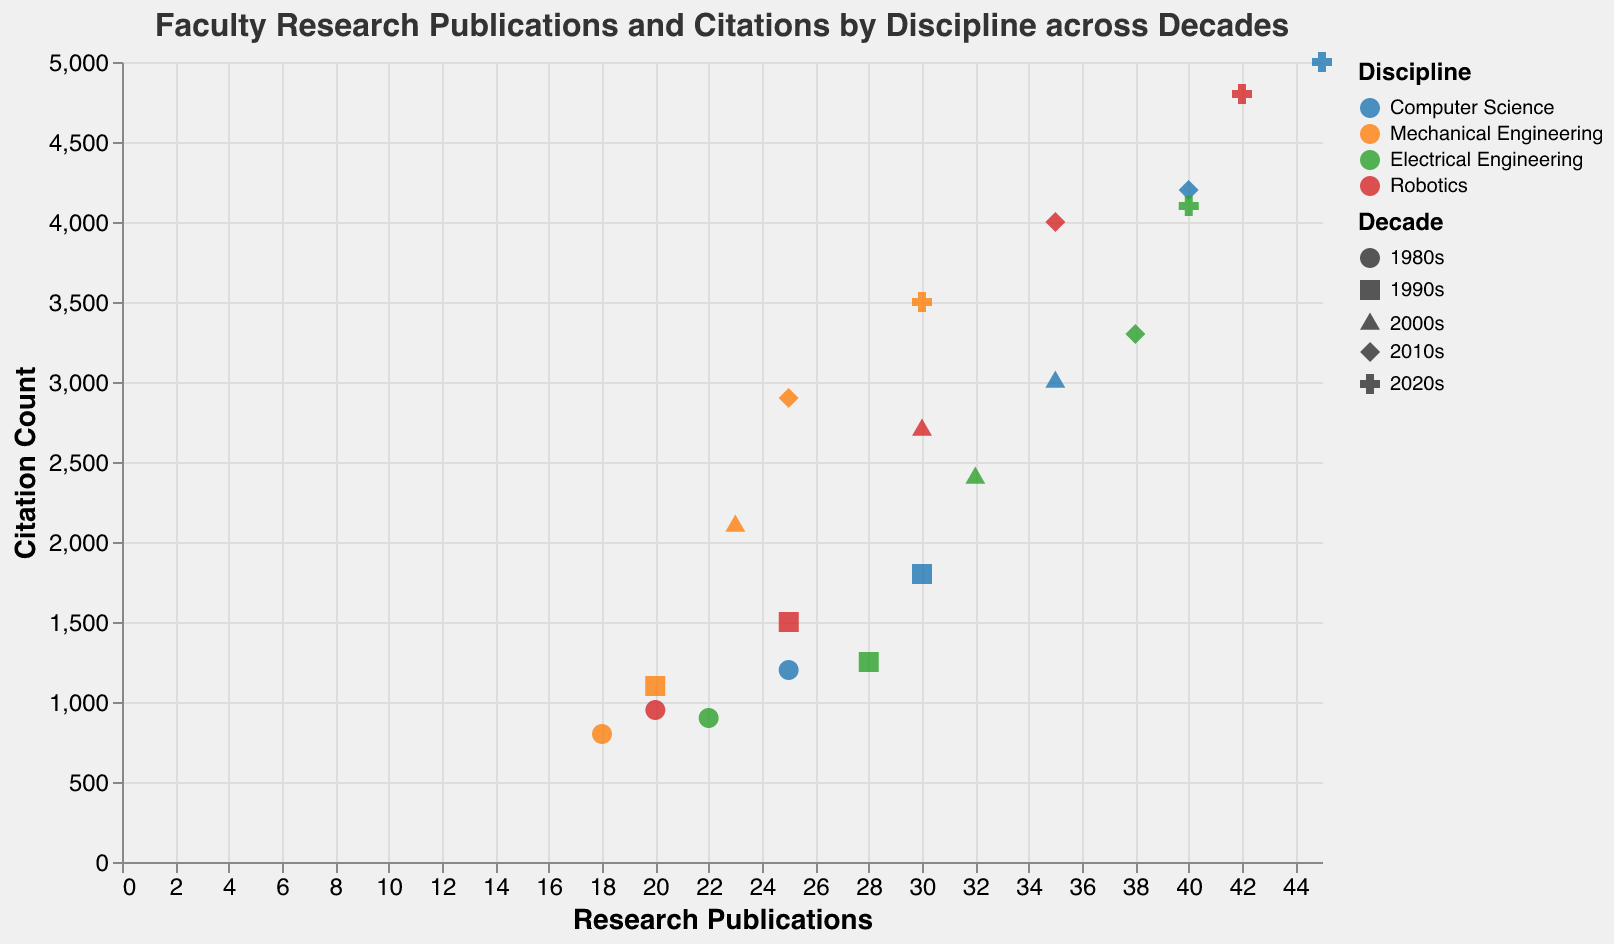What is the title of the plot? The title is located at the top of the plot and it says "Faculty Research Publications and Citations by Discipline across Decades".
Answer: Faculty Research Publications and Citations by Discipline across Decades Which discipline had the highest citation count in the 2020s? By observing the data points marked with the shape corresponding to the 2020s and comparing their citation counts, Robotics had the highest count.
Answer: Robotics How many disciplines are represented in the plot? The color legend indicates the number of different disciplines shown, which are four: Computer Science, Mechanical Engineering, Electrical Engineering, and Robotics.
Answer: 4 What shape represents the data points from the 2000s? The legend for shape indicates which shapes correspond to which decade; the triangle is used for the 2000s.
Answer: Triangle Which decade shows the highest number of research publications for Computer Science? By comparing the shapes corresponding to Computer Science across the different decades, the 2020s (represented by the cross) has the highest number of research publications for Computer Science.
Answer: 2020s What is the average citation count for Electrical Engineering in the 1990s and 2000s combined? Locate the citation counts for Electrical Engineering in the 1990s (1250) and 2000s (2400), sum them up (1250 + 2400 = 3650), and divide by 2 to get the average (3650 / 2 = 1825).
Answer: 1825 Compare the research publications of Robotics between the 1980s and 2020s. How much did it increase? The research publications for Robotics in the 1980s are 20 and in the 2020s are 42. The increase is calculated as 42 - 20 = 22.
Answer: 22 Which discipline had the least growth in citation count from the 1980s to the 2020s? By calculating the difference in citation counts for each discipline between the 1980s and 2020s, Mechanical Engineering increased from 800 to 3500, which is the smallest increase when compared with other disciplines.
Answer: Mechanical Engineering For which decade do the data points show the greatest variance in citation counts across all disciplines? Analyzing the spread of citation counts across different shapes, the 2020s have the widest spread (from around 3500 to 5000), indicating the greatest variance.
Answer: 2020s 